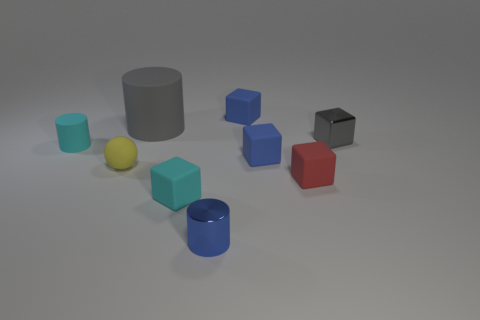Do the tiny cyan cube and the small cylinder in front of the yellow ball have the same material?
Offer a terse response. No. What number of cyan rubber cubes are there?
Keep it short and to the point. 1. How big is the blue block in front of the gray metal cube?
Ensure brevity in your answer.  Small. What number of other cyan metallic cylinders are the same size as the shiny cylinder?
Your response must be concise. 0. What is the cylinder that is both in front of the big thing and right of the rubber sphere made of?
Offer a very short reply. Metal. There is a blue cylinder that is the same size as the gray metallic block; what is its material?
Your answer should be very brief. Metal. What size is the rubber object that is on the right side of the tiny blue rubber block in front of the small cyan object to the left of the cyan block?
Provide a short and direct response. Small. There is a gray object that is the same material as the small cyan cylinder; what size is it?
Your answer should be compact. Large. Is the size of the gray block the same as the blue matte thing that is in front of the tiny gray shiny object?
Provide a short and direct response. Yes. What is the shape of the cyan matte object that is on the right side of the yellow matte sphere?
Offer a terse response. Cube. 